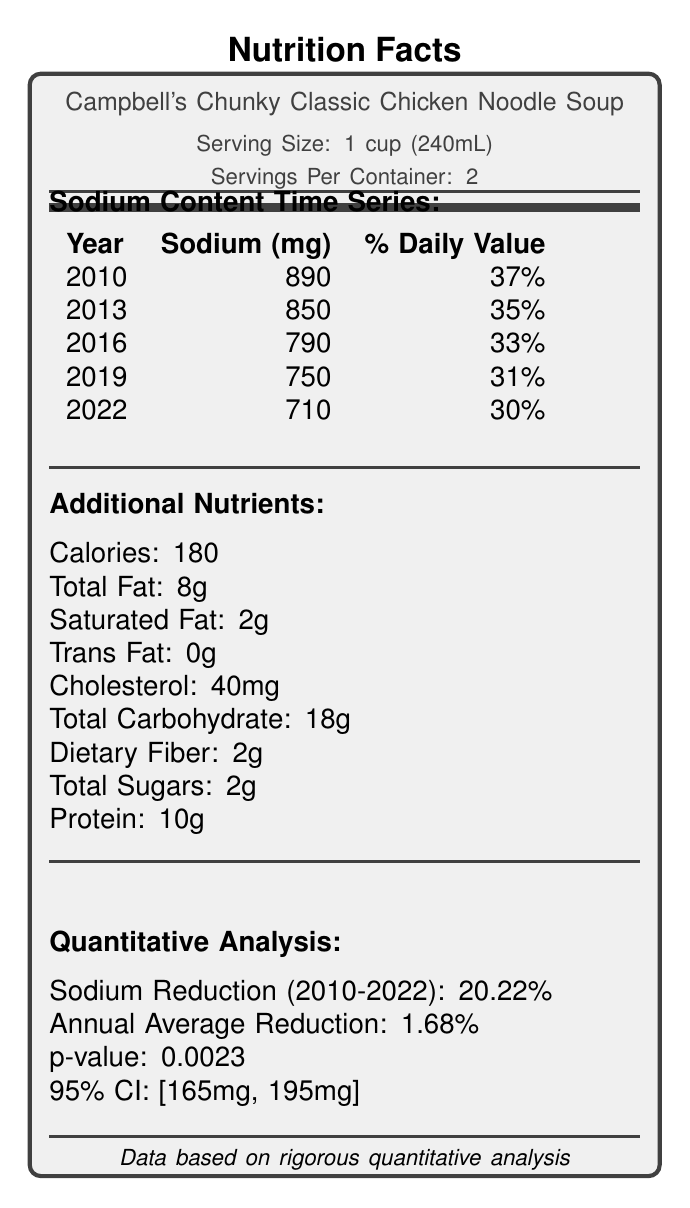what is the serving size of the product? The serving size is clearly listed below the product name on the document's upper section.
Answer: 1 cup (240mL) how much sodium (mg) did the soup contain in 2016? The sodium content for the year 2016 is listed in the Sodium Content Time Series table in the document.
Answer: 790 mg what is the percentage daily value for sodium in 2022? The percentage daily value for sodium in 2022 is shown in the Sodium Content Time Series table as 30%.
Answer: 30% how many servings are there per container? The servings per container are mentioned at the top part of the document beneath the product name.
Answer: 2 what is the cholesterol content per serving? The cholesterol content per serving is listed under the Additional Nutrients section in the document.
Answer: 40 mg what is the p-value for the sodium reduction analysis? The p-value is listed in the Quantitative Analysis section under Sodium Reduction (2010-2022).
Answer: 0.0023 what ingredient is used as a partial salt substitute? The ingredient list mentions potassium chloride as one of the sodium reduction methods.
Answer: Potassium chloride what is the statistical significance confidence interval for sodium reduction? The 95% confidence interval is detailed in the Quantitative Analysis section.
Answer: [165 mg, 195 mg] which year did the soup have the highest sodium content?  
A. 2010  
B. 2013  
C. 2016  
D. 2019 The data shows that 2010 had the highest sodium content at 890 mg.
Answer: A what is the annual average reduction rate in sodium content?  
1. 1.68%  
2. 2.5%  
3. 3.1%  
4. 0.8% The annual average reduction rate of 1.68% is mentioned in the Quantitative Analysis section.
Answer: 1 does the document state a correlation between sodium reduction and sales? The Quantitative Analysis section shows a weak negative correlation with a Pearson coefficient of -0.12.
Answer: Yes how does the soup's sodium content in 2022 compare to the average sodium content of all brands? The average sodium content of all brands in 2022 is 780 mg, while the soup's sodium content is 710 mg, which is lower.
Answer: Lower summarize the main ideas presented in the document. The summary captures the essential elements: changes in sodium content over the years, methods for reduction, quantitative analysis results, market comparisons, and health implications.
Answer: The document provides an overview of the nutritional content and sodium reduction strategies for Campbell's Chunky Classic Chicken Noodle Soup over the years 2010 to 2022. It highlights the gradual reduction in sodium content, the methods used for achieving this reduction, and the quantitative analysis confirming the statistical significance of these changes. Additionally, a comparison with market averages is presented, and the health implications of reduced sodium content are discussed. what is the sodium content for all other top competitors in 2022? The document only provides the average sodium content for all brands and top competitors but not for individual competitors.
Answer: Not enough information what method was used to collect data on sodium content? The Research Methodology section specifies this data collection method.
Answer: Quarterly laboratory analysis of random product samples 